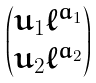<formula> <loc_0><loc_0><loc_500><loc_500>\begin{pmatrix} u _ { 1 } \ell ^ { a _ { 1 } } \\ u _ { 2 } \ell ^ { a _ { 2 } } \end{pmatrix}</formula> 